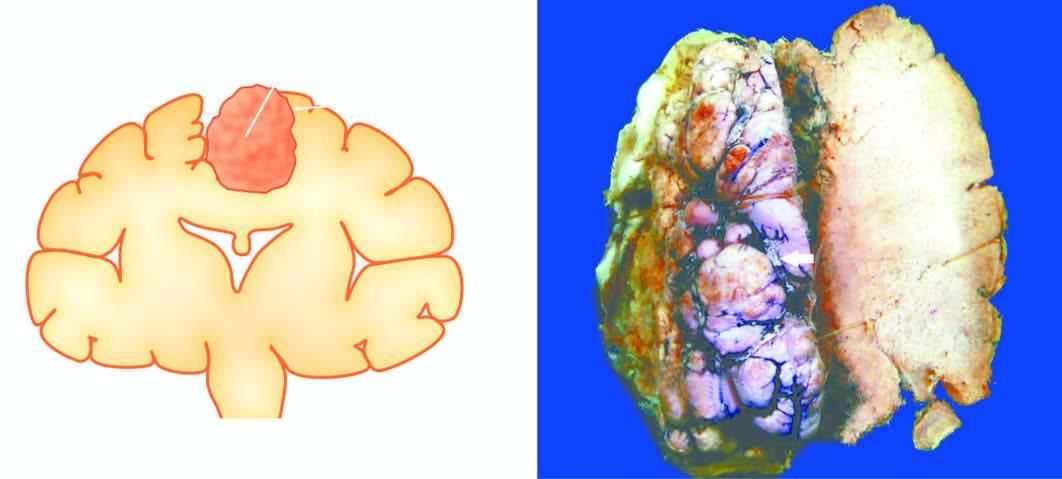s cut surface of the mass firm and fibrous?
Answer the question using a single word or phrase. Yes 